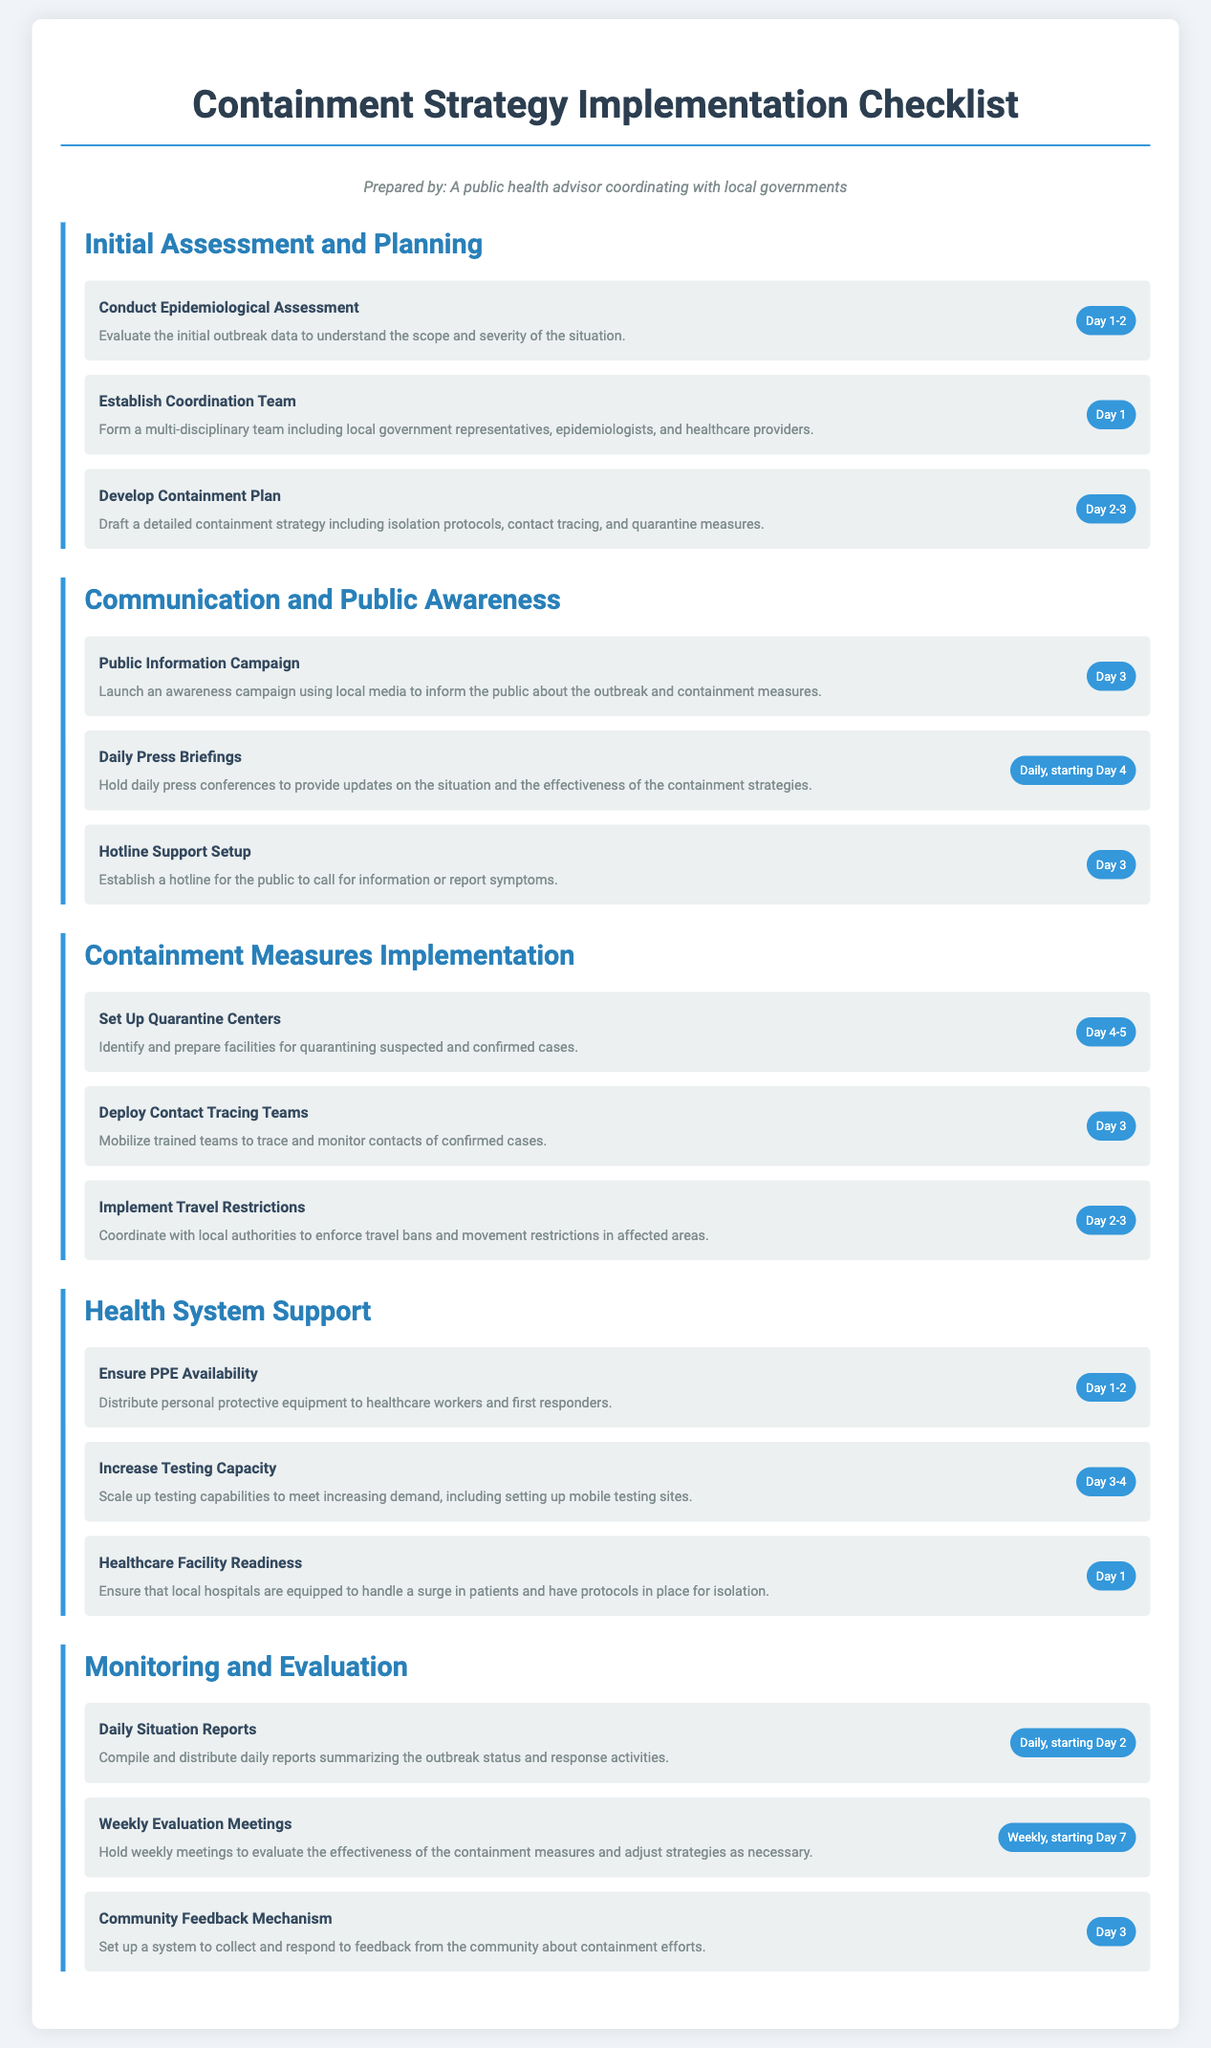What is the deadline for conducting the epidemiological assessment? The deadline for conducting the epidemiological assessment is specified as Day 1-2 in the document.
Answer: Day 1-2 What is one action taken during the communication and public awareness phase? One action during this phase is the public information campaign, aimed at informing the public about the outbreak and containment measures on Day 3.
Answer: Public Information Campaign How many days are allocated for the development of the containment plan? The document lists the development of the containment plan with a deadline from Day 2-3, indicating a total of two days for this action.
Answer: 2 days What is the frequency of daily press briefings starting from Day 4? The document states that daily press briefings are to be held starting Day 4, indicating a frequency of once per day.
Answer: Daily Which action is required on Day 1 regarding healthcare facilities? The document specifies that on Day 1, the action to ensure healthcare facility readiness must be undertaken to equip local hospitals for patient surges.
Answer: Ensure Healthcare Facility Readiness How often are the evaluation meetings scheduled? The evaluation meetings are scheduled weekly, starting on Day 7, as outlined in the monitoring and evaluation section.
Answer: Weekly What is the purpose of the hotline support setup? The hotline support setup is established for the public to call for information or report symptoms, as described in the communication and public awareness section.
Answer: Information and report symptoms What is one responsibility of the quarantine centers? The responsibility of the quarantine centers is to identify and prepare facilities for quarantining suspected and confirmed cases, as noted in the containment measures implementation section.
Answer: Quarantining suspected and confirmed cases 